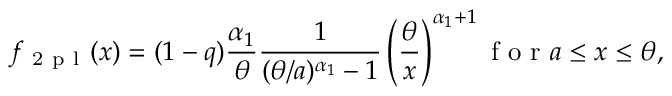Convert formula to latex. <formula><loc_0><loc_0><loc_500><loc_500>f _ { 2 p l } ( x ) = ( 1 - q ) \frac { \alpha _ { 1 } } { \theta } \frac { 1 } ( \theta / a ) ^ { \alpha _ { 1 } } - 1 } \left ( \frac { \theta } { x } \right ) ^ { \alpha _ { 1 } + 1 } f o r a \leq x \leq \theta ,</formula> 